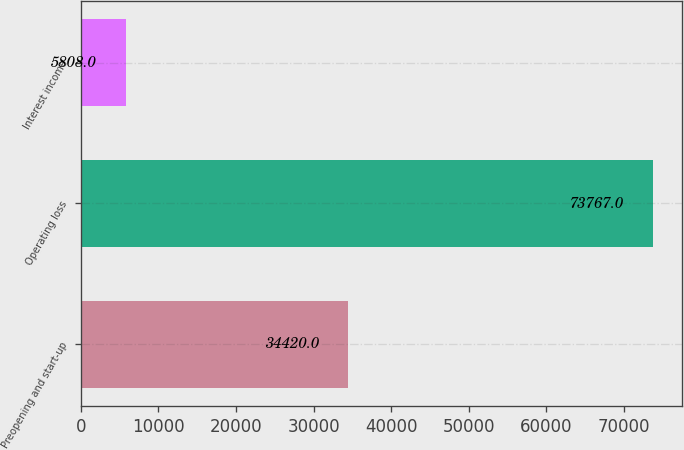Convert chart to OTSL. <chart><loc_0><loc_0><loc_500><loc_500><bar_chart><fcel>Preopening and start-up<fcel>Operating loss<fcel>Interest income<nl><fcel>34420<fcel>73767<fcel>5808<nl></chart> 